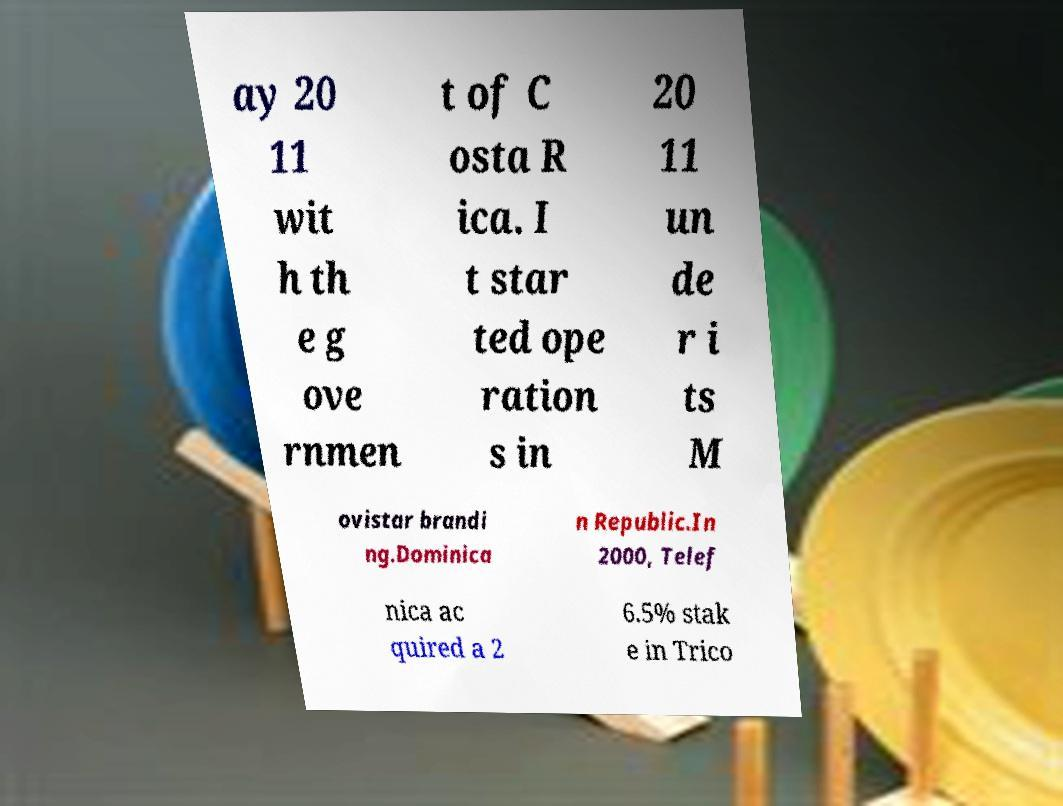Could you extract and type out the text from this image? ay 20 11 wit h th e g ove rnmen t of C osta R ica. I t star ted ope ration s in 20 11 un de r i ts M ovistar brandi ng.Dominica n Republic.In 2000, Telef nica ac quired a 2 6.5% stak e in Trico 